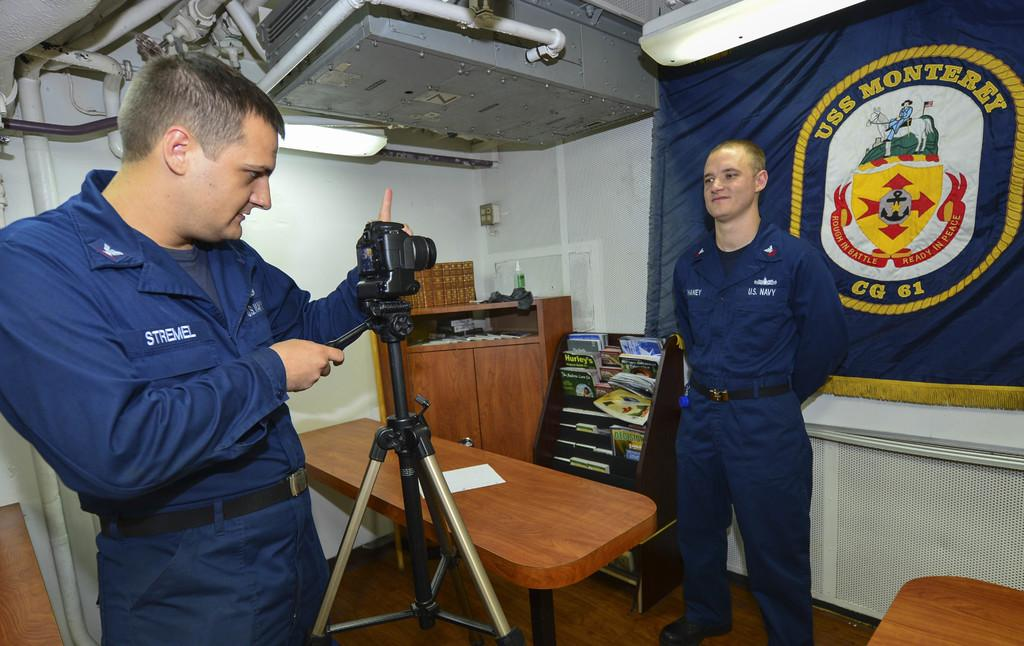How many people are in the image? There are two men in the image. What are the two men doing in the image? The two men are standing, and one of them is taking a photo of another person using a camera. What type of crate is being used to mark the territory in the image? There is no crate or territory present in the image; it features two men standing and one taking a photo. What type of quill is being used by the man to write a note in the image? There is no quill or writing activity present in the image; it features two men standing and one taking a photo. 